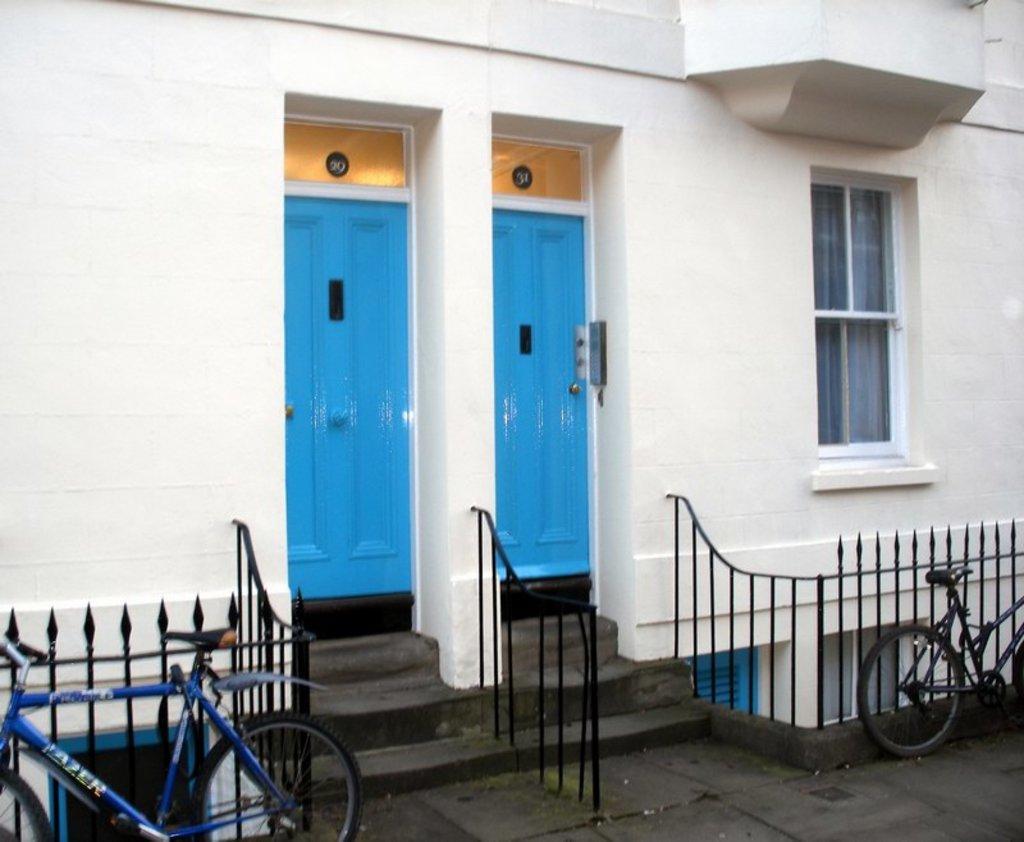Can you describe this image briefly? This looks like a house with a window and doors. These doors are blue in color. These are the stairs with the staircase holders. I can see two bicycles, which are parked. This looks like an iron grill, which is black in color. 